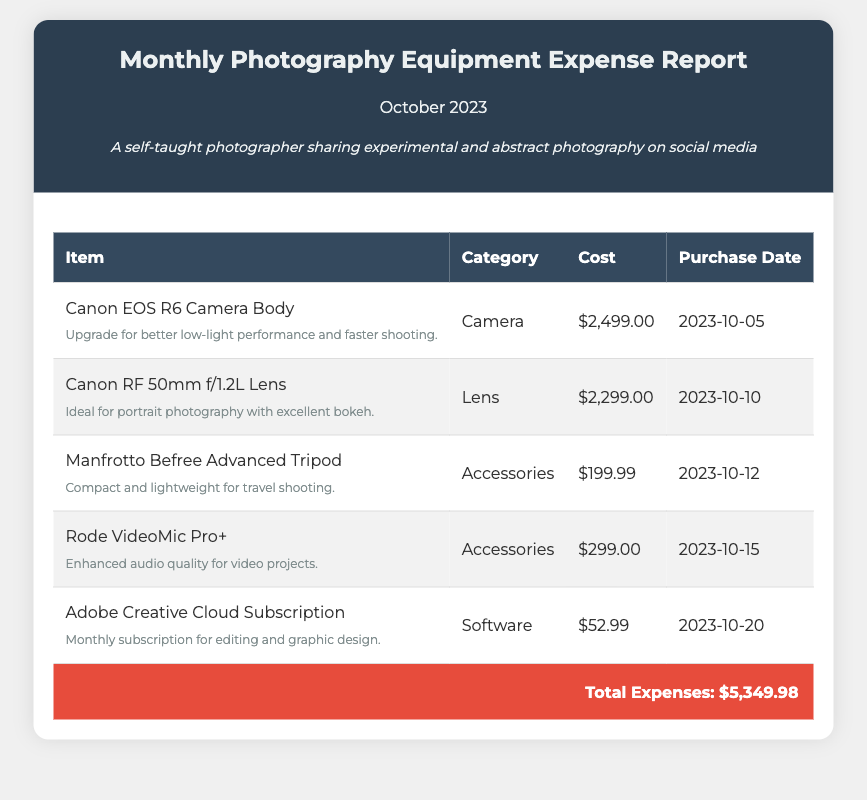What is the total expense for October 2023? The total expense is calculated by adding up all the costs listed in the document.
Answer: $5,349.98 When was the Canon RF 50mm f/1.2L Lens purchased? The purchase date for the Canon RF 50mm f/1.2L Lens is noted in the document.
Answer: 2023-10-10 What category does the Rode VideoMic Pro+ fall under? The category for the Rode VideoMic Pro+ is specified in the document as part of the accessories.
Answer: Accessories How much did the Canon EOS R6 Camera Body cost? The cost of the Canon EOS R6 Camera Body is explicitly listed in the document.
Answer: $2,499.00 What was the purpose of purchasing the Manfrotto Befree Advanced Tripod? The document provides notes about the item that indicate its purpose.
Answer: Compact and lightweight for travel shooting Total accessories expenses? The total expenses for accessories are calculated by combining the costs of all accessories listed in the table.
Answer: $498.99 What item was purchased on October 20, 2023? The document lists the specific purchases with their respective dates.
Answer: Adobe Creative Cloud Subscription 